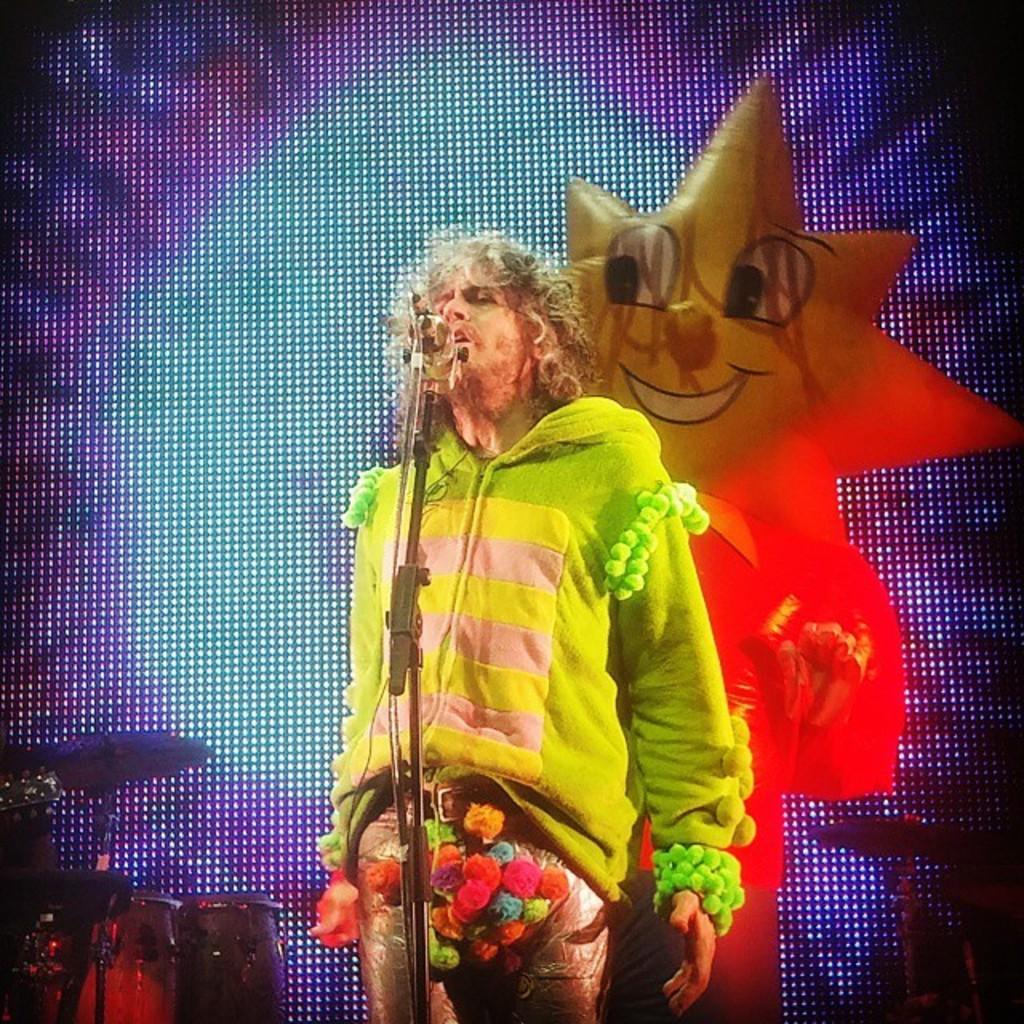Could you give a brief overview of what you see in this image? In this image we can see a man standing. We can also see a mic with a stand, some musical instruments and the picture on the screen. 